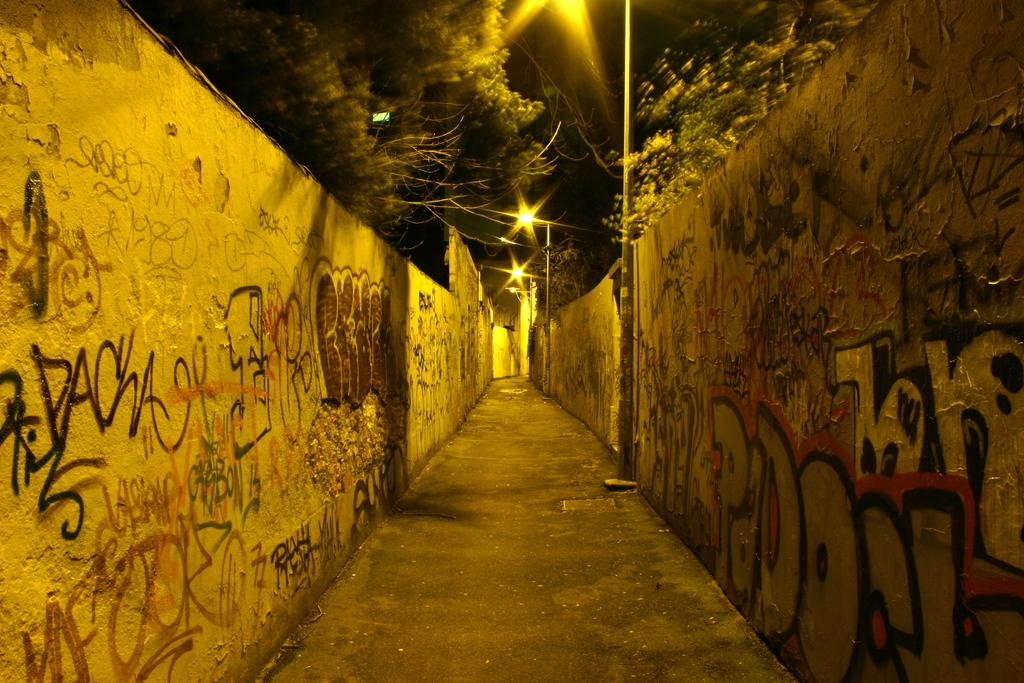What type of path is visible in the image? There is a walkway in the image. What decorative elements can be seen on the walls? There are paintings on the walls. What type of natural elements are visible at the top of the image? Trees are visible at the top of the image. What structures are present at the top of the image? There is a pole and street lights at the top of the image. How would you describe the lighting conditions in the image? The background of the image is dark. What type of iron distribution system is present in the image? There is no iron distribution system present in the image. How is the bait being used in the image? There is no bait present in the image. 